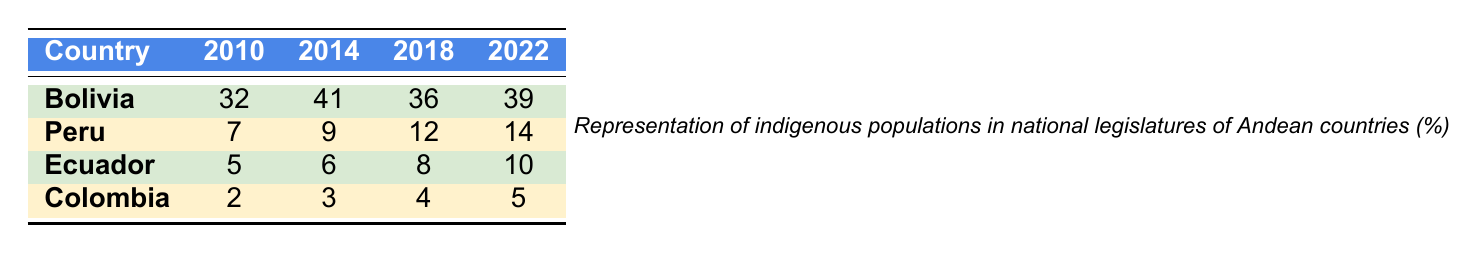What is the representation of indigenous populations in the Bolivian legislature in 2014? In the table, the value corresponding to Bolivia for the year 2014 is directly listed. The representation is 41%.
Answer: 41% Which country had the lowest representation of indigenous populations in 2010? According to the table, Colombia had the lowest representation in 2010, with a value of 2%.
Answer: Colombia What is the average representation of indigenous populations for Ecuador from 2010 to 2022? To find the average, add the values for Ecuador across the years: 5 + 6 + 8 + 10 = 29. Divide this sum by the number of years (4): 29 / 4 = 7.25.
Answer: 7.25% Did Peru's representation of indigenous populations increase in 2018 compared to 2014? In the table, Peru's representation was 9% in 2014 and increased to 12% in 2018. Therefore, it did increase.
Answer: Yes What is the total representation for all countries in 2022? To calculate the total for 2022, add the representation of each country in that year: 39 (Bolivia) + 14 (Peru) + 10 (Ecuador) + 5 (Colombia) = 68.
Answer: 68% Which country saw the largest increase in representation from 2010 to 2018? Analyzing the data, Bolivia's representation went from 32% in 2010 to 36% in 2018, an increase of 4%. Peru's representation increased from 7% to 12%, which is 5%. This is larger than the increases of Ecuador or Colombia.
Answer: Peru How many more percent points of representation did Bolivia have over Colombia in 2022? In 2022, Bolivia had 39% representation and Colombia had 5%. To find the difference, subtract Colombia's percentage from Bolivia's: 39 - 5 = 34.
Answer: 34% What was the trend in indigenous representation in Colombia from 2010 to 2022? By looking at the values in the table, Colombia's representation increased from 2% in 2010 to 5% in 2022. This shows a gradual increase, but it's very small relative to other countries.
Answer: Gradual increase In which year did Ecuador first surpass its earlier representation from 2010? The data shows that Ecuador's representation in 2014 was 6%, and it continued to surpass its 2010 representation of 5% in 2014 and thereafter.
Answer: 2014 